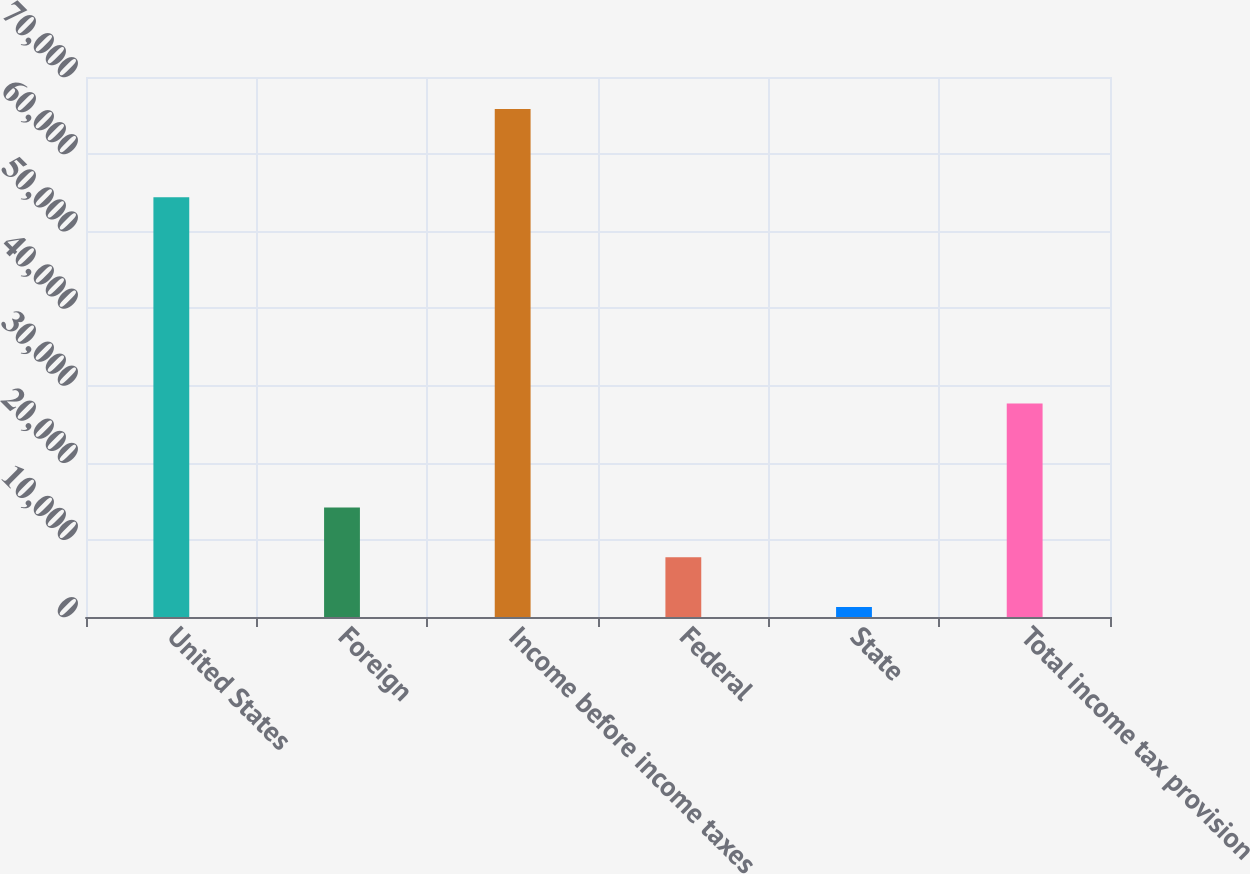<chart> <loc_0><loc_0><loc_500><loc_500><bar_chart><fcel>United States<fcel>Foreign<fcel>Income before income taxes<fcel>Federal<fcel>State<fcel>Total income tax provision<nl><fcel>54406<fcel>14194.8<fcel>65838<fcel>7739.4<fcel>1284<fcel>27691<nl></chart> 